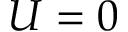Convert formula to latex. <formula><loc_0><loc_0><loc_500><loc_500>U = 0</formula> 